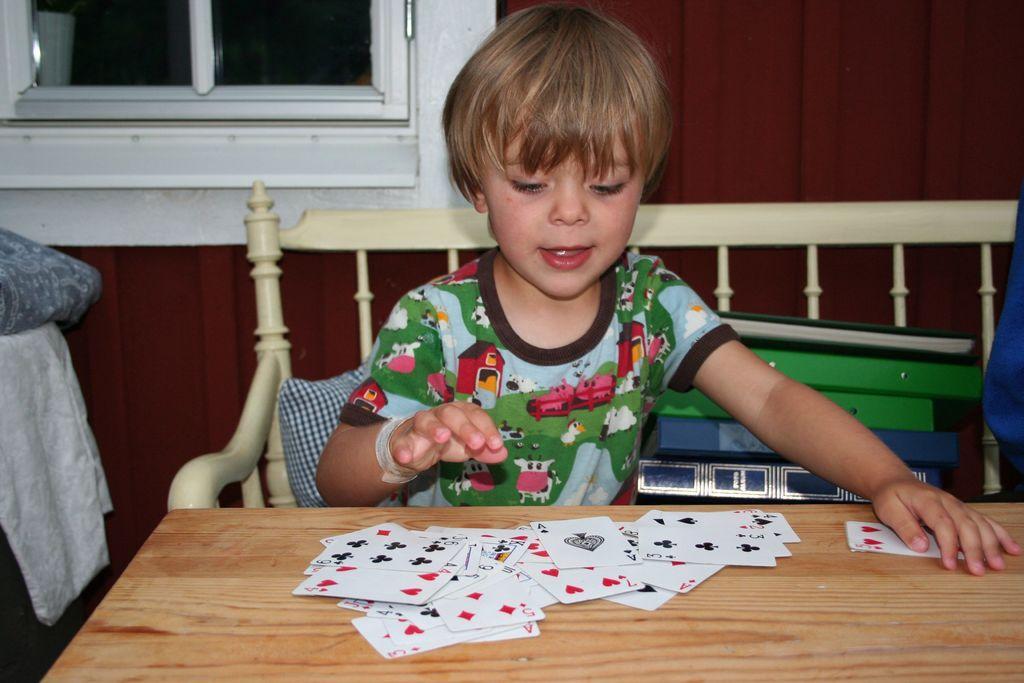Describe this image in one or two sentences. This picture is clicked inside the room. Boy in green and blue t-shirt is sitting on chair in front of a table on which playing cards are placed. Beside him, we see many books and behind him, we see a brown wall and windows. 